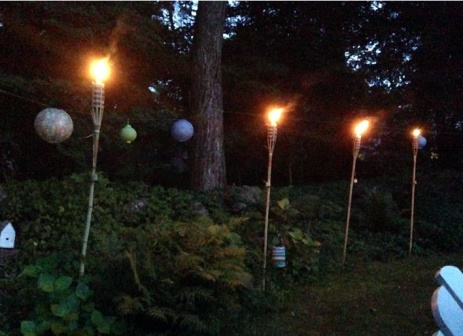What do the tiki torches and lanterns symbolize in this image? The tiki torches and lanterns in this image symbolize warmth, light, and guidance amidst the darkness. The flames of the torches represent a beacon of hope and comfort, illuminating the path and creating a sense of safety and protection. The paper lanterns, with their delicate glow, evoke notions of creativity, celebration, and the gentle passage of time. Together, these elements suggest a harmonious blend of human ingenuity and the natural world's beauty, fostering an atmosphere of tranquility and introspection. 